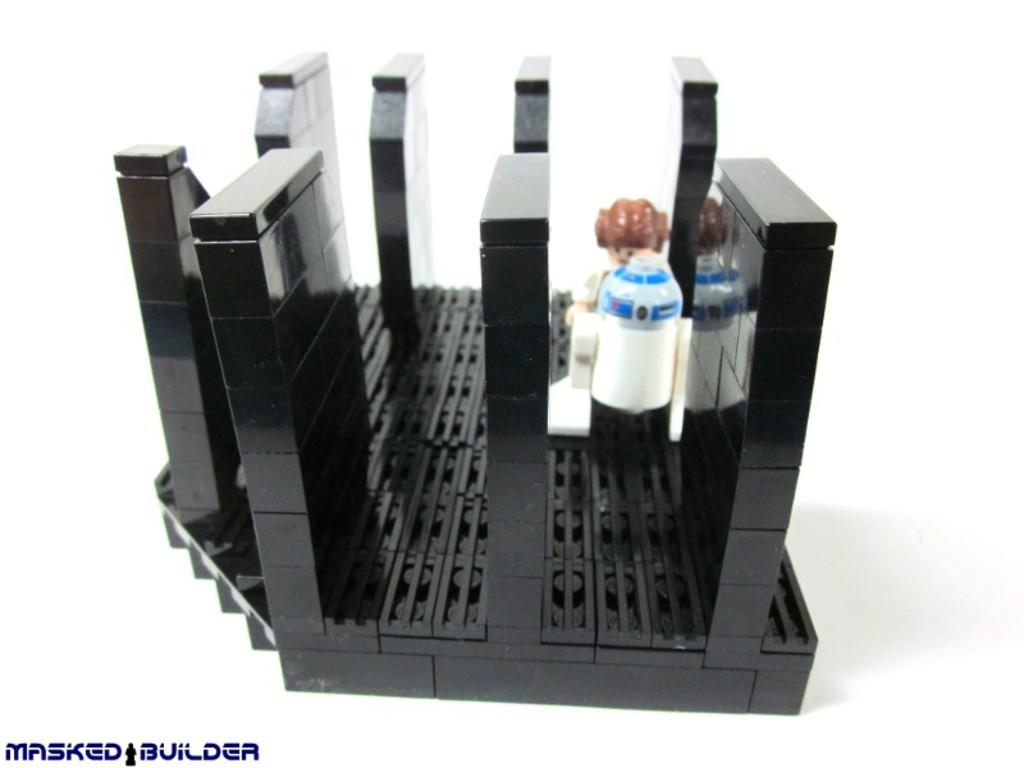<image>
Write a terse but informative summary of the picture. BLack legos with two figures from star wars by Masked builders 